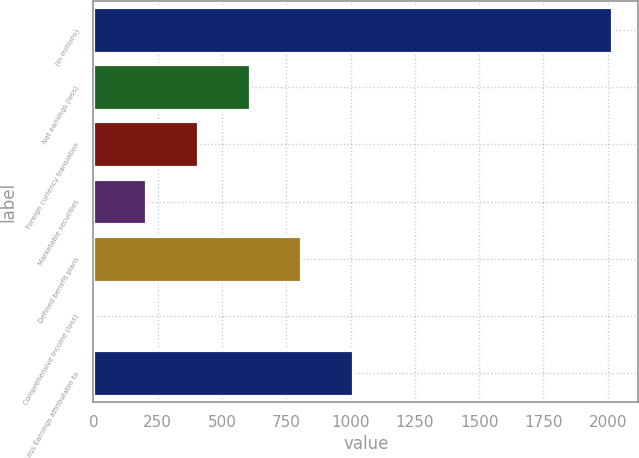Convert chart to OTSL. <chart><loc_0><loc_0><loc_500><loc_500><bar_chart><fcel>(In millions)<fcel>Net earnings (loss)<fcel>Foreign currency translation<fcel>Marketable securities<fcel>Defined benefit plans<fcel>Comprehensive income (loss)<fcel>Less Earnings attributable to<nl><fcel>2017<fcel>607.9<fcel>406.6<fcel>205.3<fcel>809.2<fcel>4<fcel>1010.5<nl></chart> 